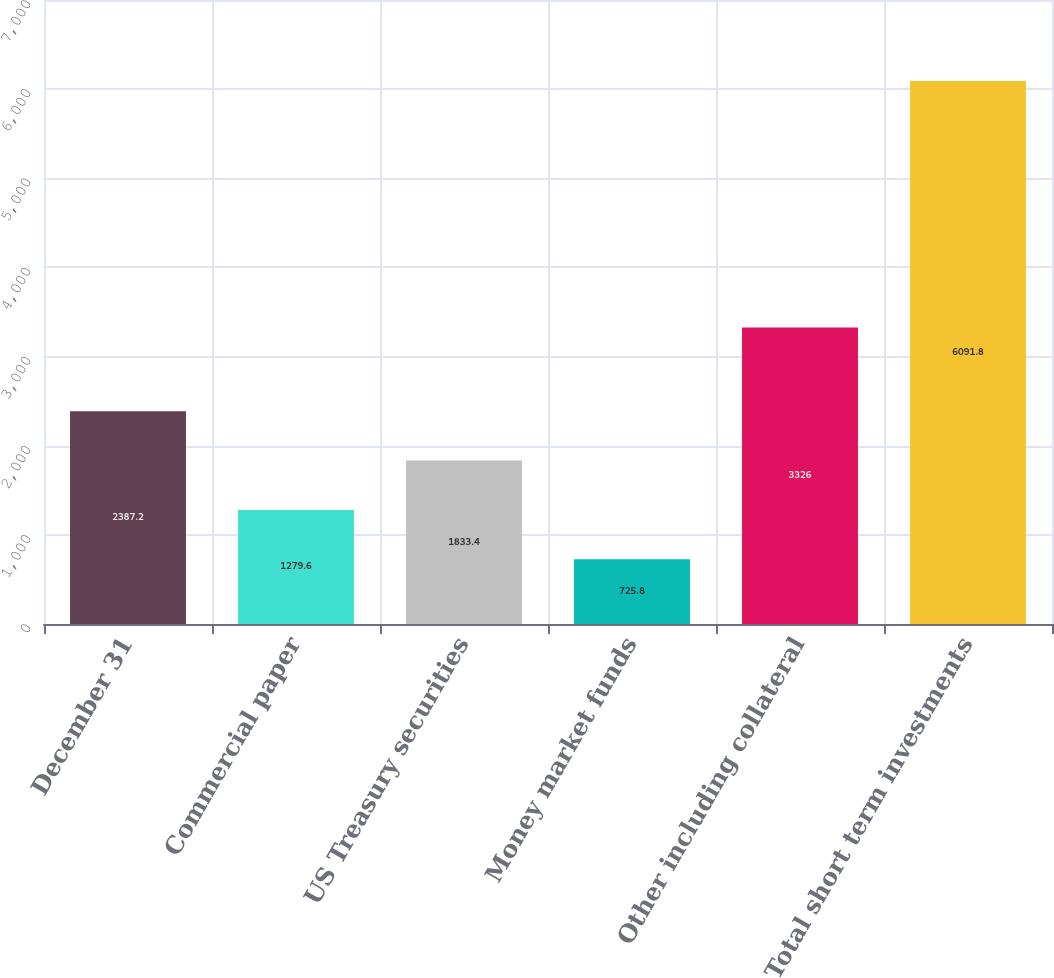<chart> <loc_0><loc_0><loc_500><loc_500><bar_chart><fcel>December 31<fcel>Commercial paper<fcel>US Treasury securities<fcel>Money market funds<fcel>Other including collateral<fcel>Total short term investments<nl><fcel>2387.2<fcel>1279.6<fcel>1833.4<fcel>725.8<fcel>3326<fcel>6091.8<nl></chart> 